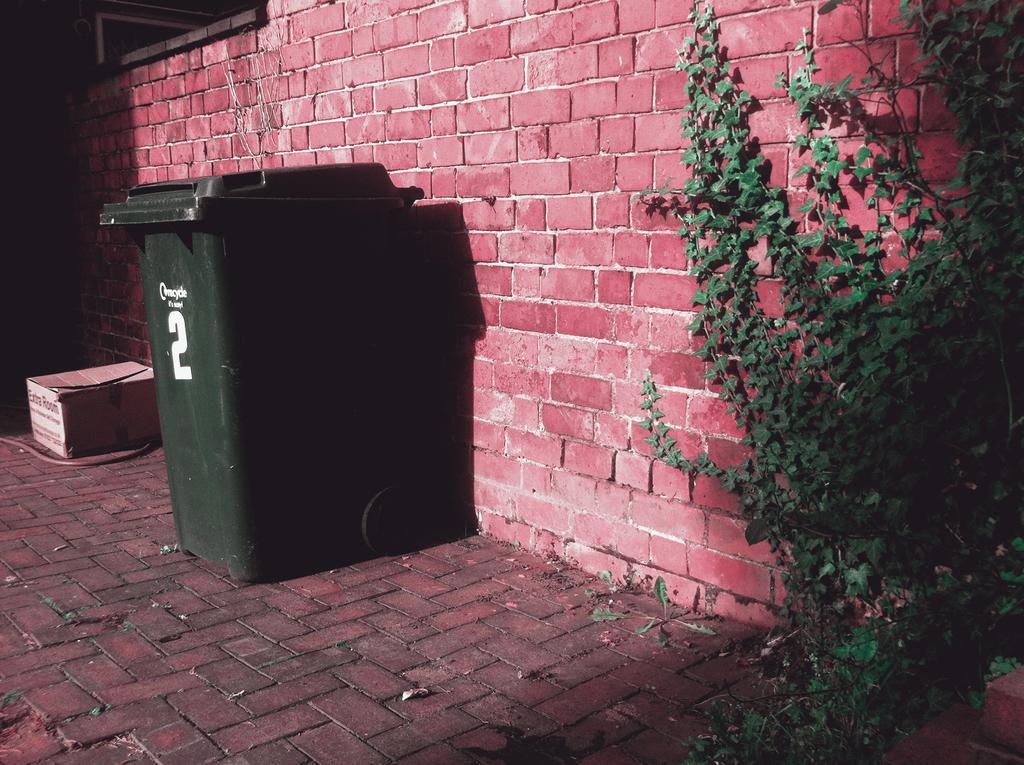What number is on the trash can?
Offer a very short reply. 2. We use trash pin regularly?
Your answer should be compact. Yes. 